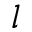<formula> <loc_0><loc_0><loc_500><loc_500>l</formula> 